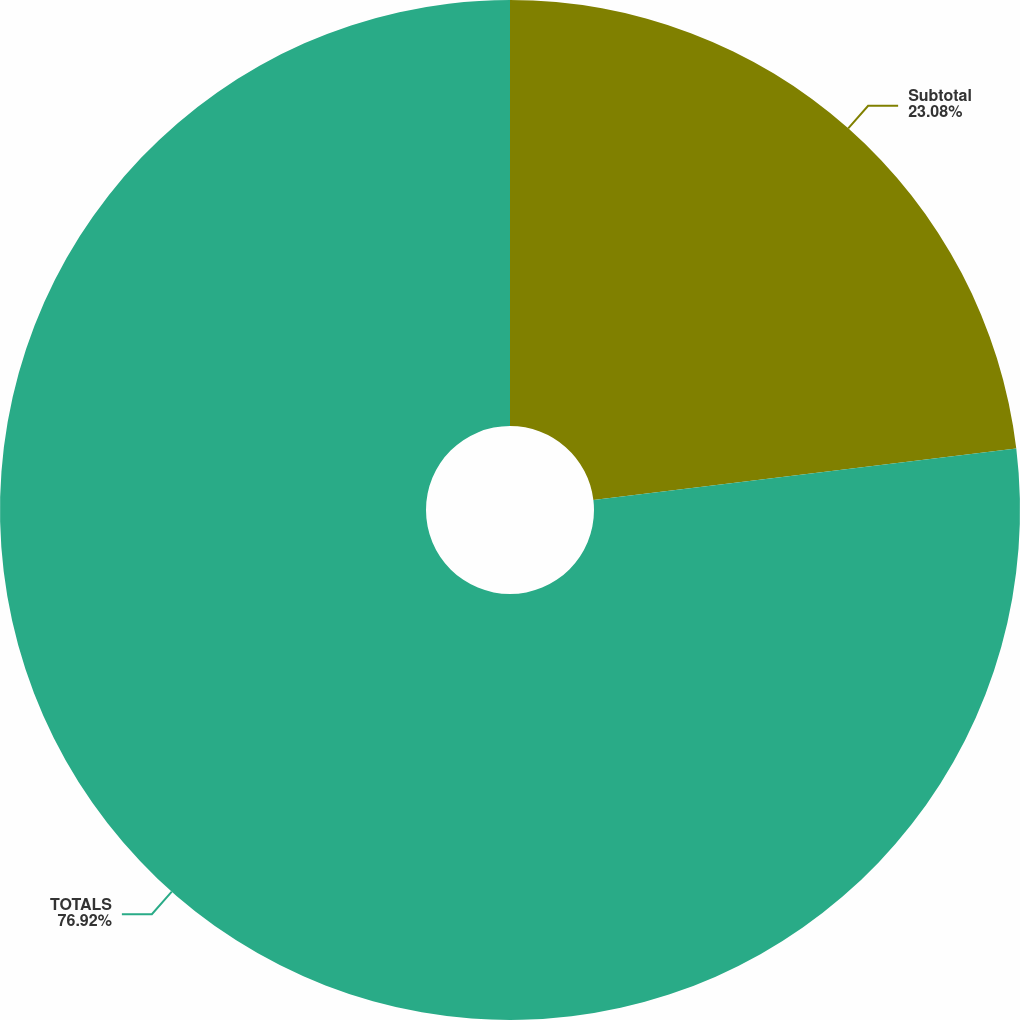<chart> <loc_0><loc_0><loc_500><loc_500><pie_chart><fcel>Subtotal<fcel>TOTALS<nl><fcel>23.08%<fcel>76.92%<nl></chart> 